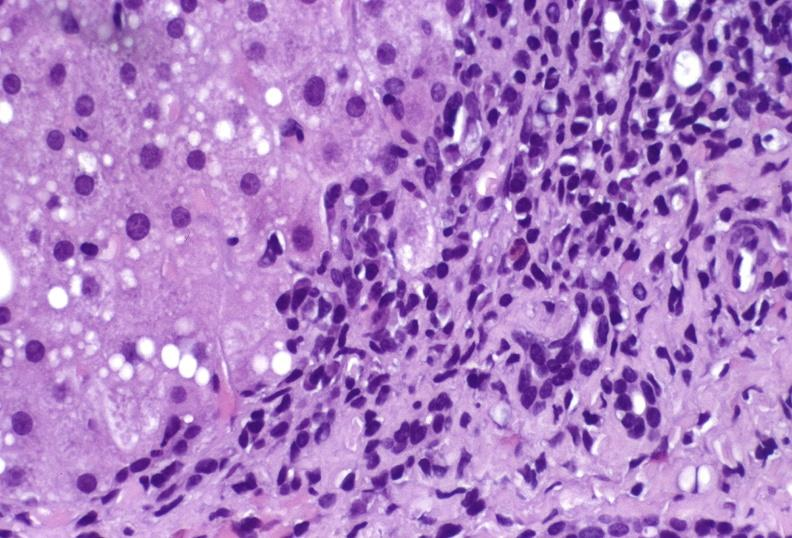s cardiovascular present?
Answer the question using a single word or phrase. No 